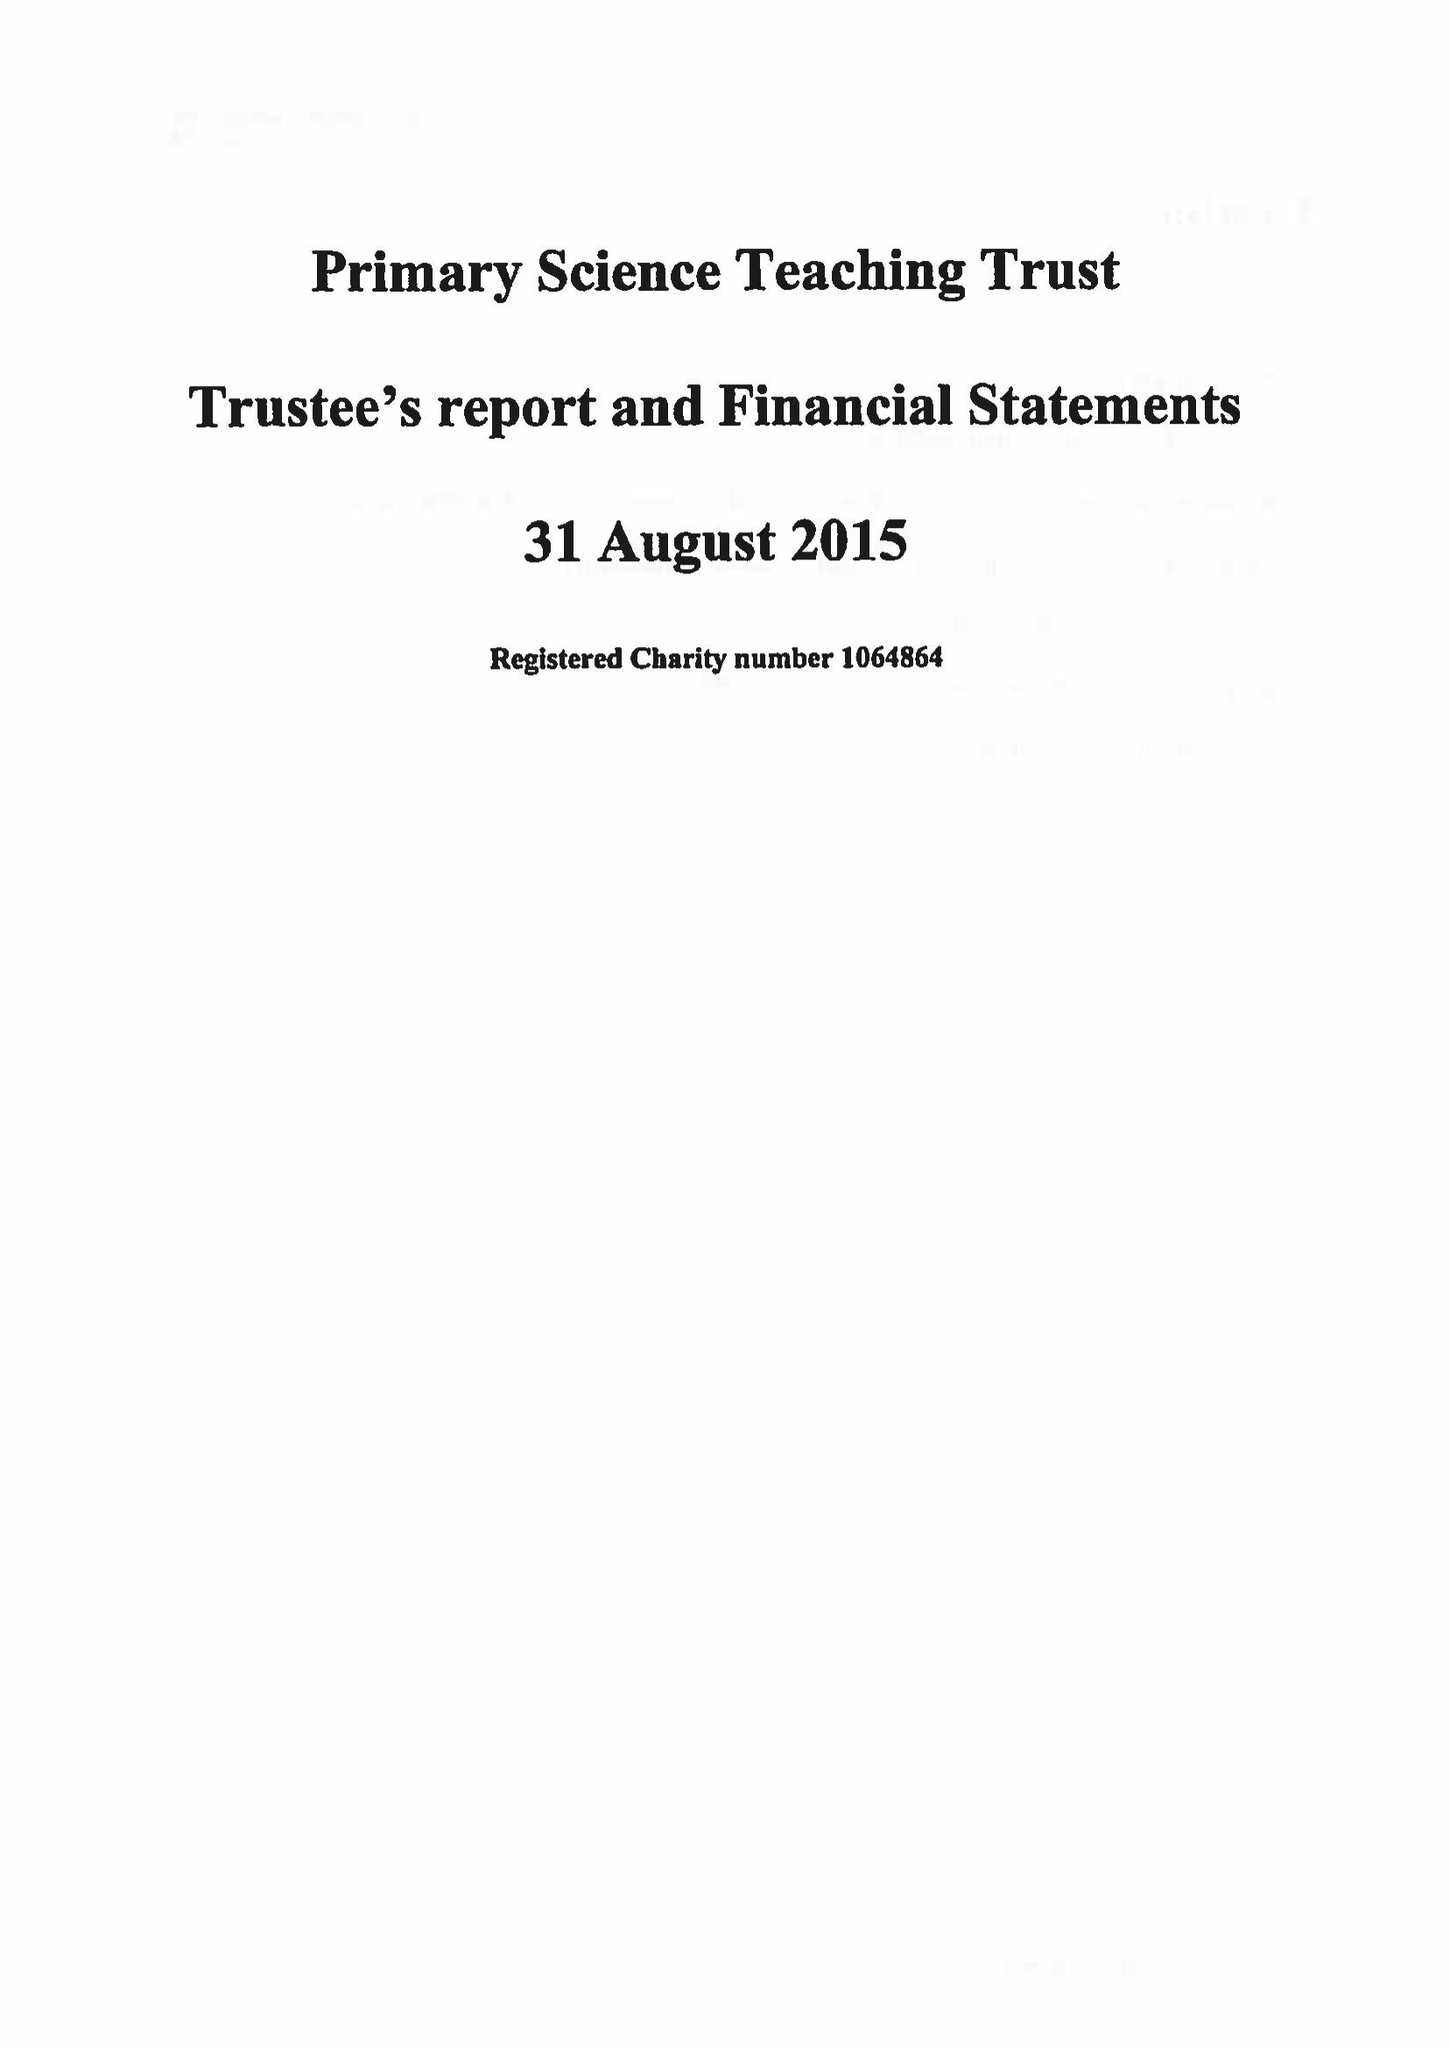What is the value for the address__postcode?
Answer the question using a single word or phrase. BS8 1PD 